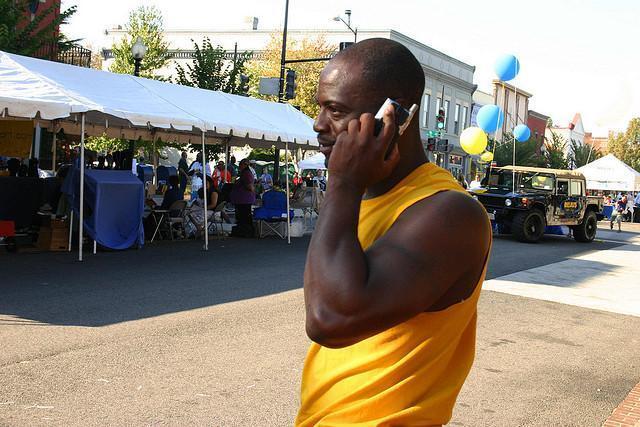How many balloons are in the photo?
Give a very brief answer. 5. How many cats have their eyes closed?
Give a very brief answer. 0. 